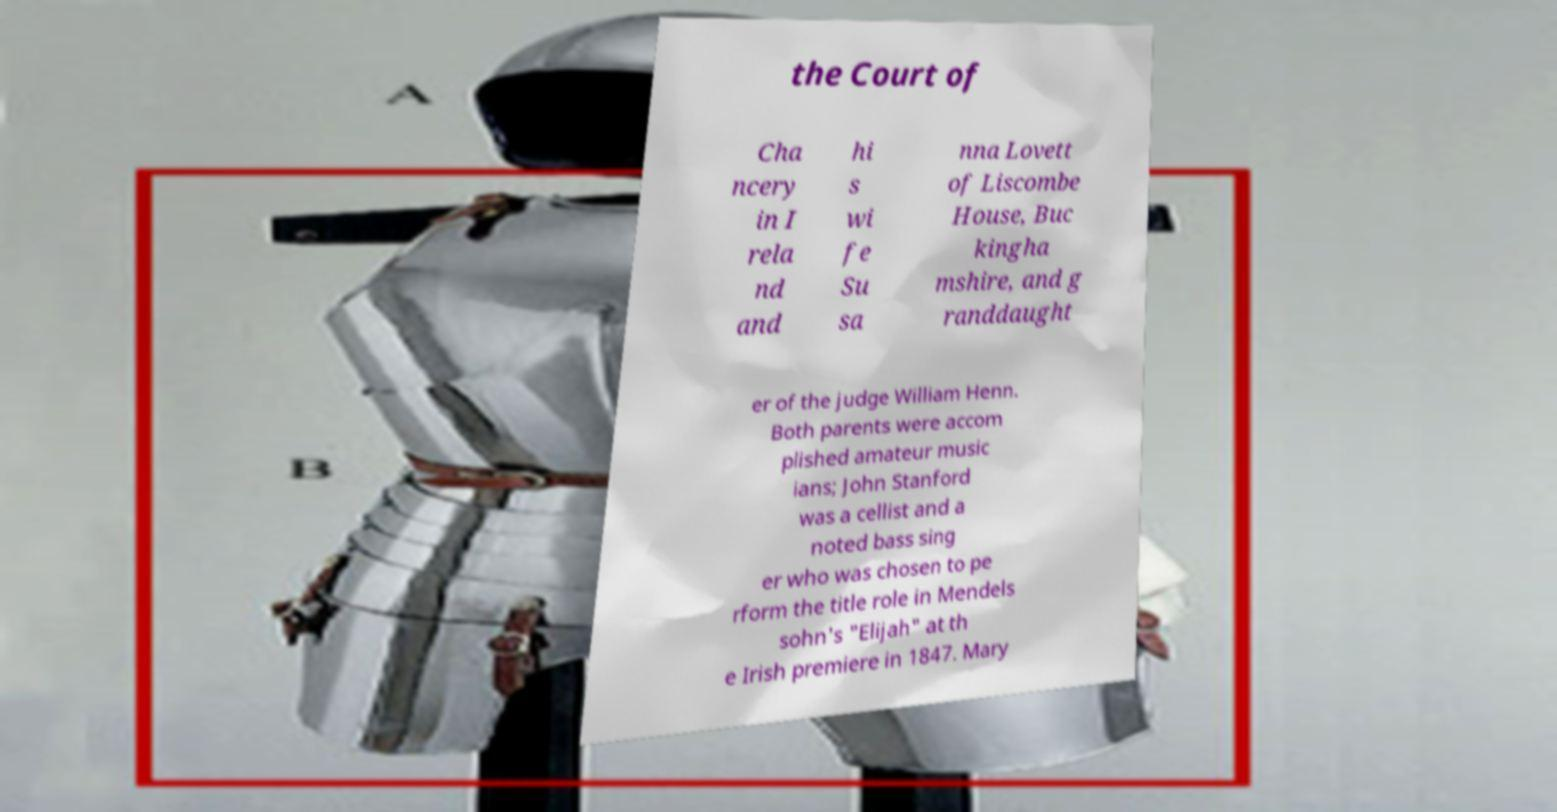Could you assist in decoding the text presented in this image and type it out clearly? the Court of Cha ncery in I rela nd and hi s wi fe Su sa nna Lovett of Liscombe House, Buc kingha mshire, and g randdaught er of the judge William Henn. Both parents were accom plished amateur music ians; John Stanford was a cellist and a noted bass sing er who was chosen to pe rform the title role in Mendels sohn's "Elijah" at th e Irish premiere in 1847. Mary 